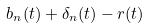Convert formula to latex. <formula><loc_0><loc_0><loc_500><loc_500>b _ { n } ( t ) + \delta _ { n } ( t ) - r ( t )</formula> 